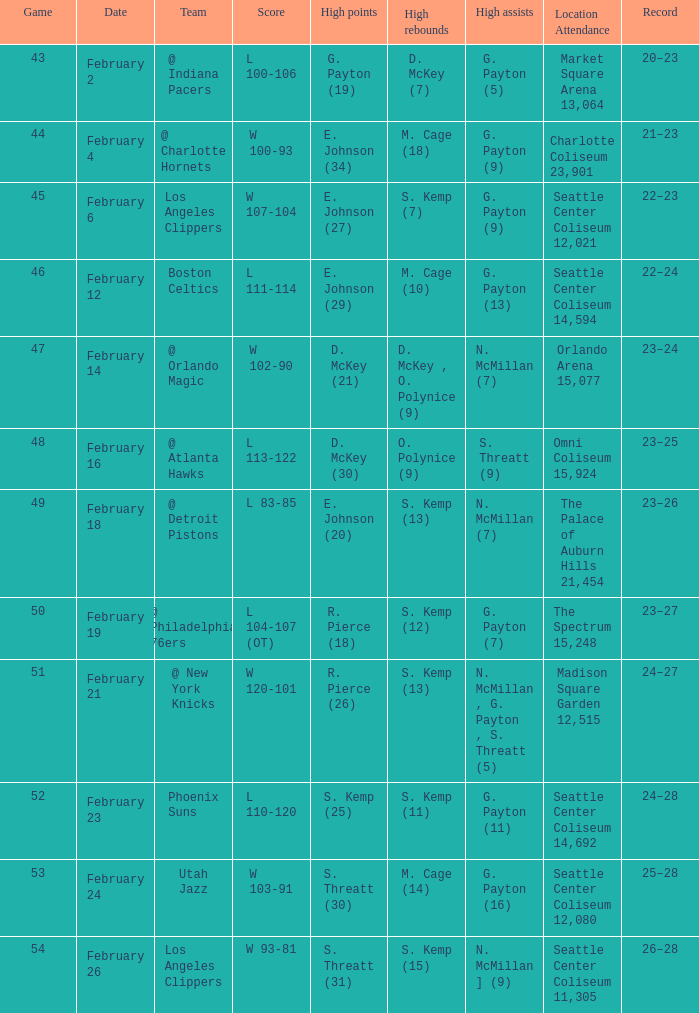What is the record for the Utah Jazz? 25–28. 